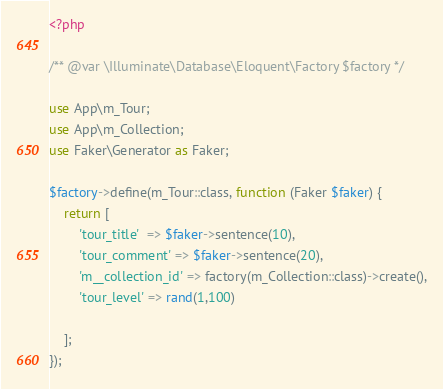<code> <loc_0><loc_0><loc_500><loc_500><_PHP_><?php

/** @var \Illuminate\Database\Eloquent\Factory $factory */

use App\m_Tour;
use App\m_Collection;
use Faker\Generator as Faker;

$factory->define(m_Tour::class, function (Faker $faker) {
    return [
        'tour_title'  => $faker->sentence(10),
        'tour_comment' => $faker->sentence(20),
        'm__collection_id' => factory(m_Collection::class)->create(),
        'tour_level' => rand(1,100)

    ];
});
</code> 